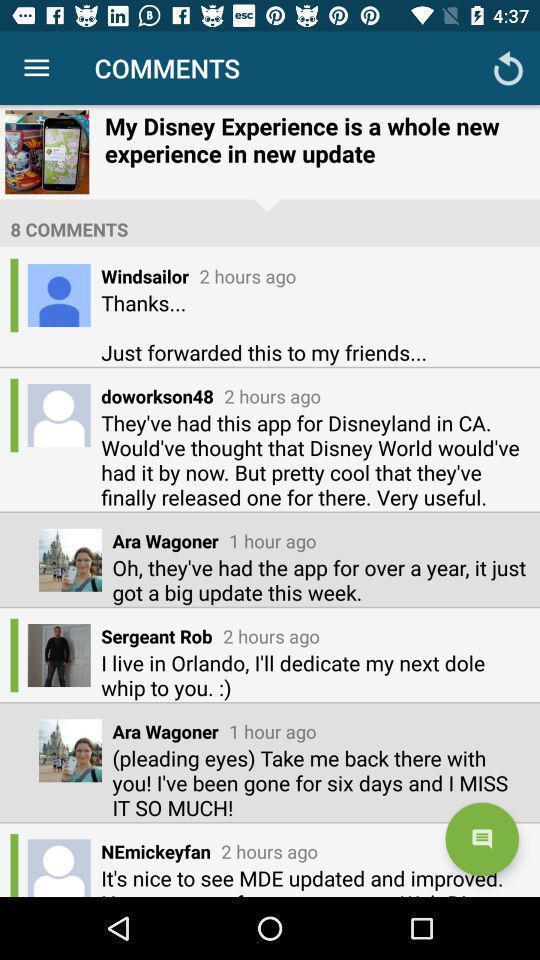Provide a description of this screenshot. Screen shows comments option. 